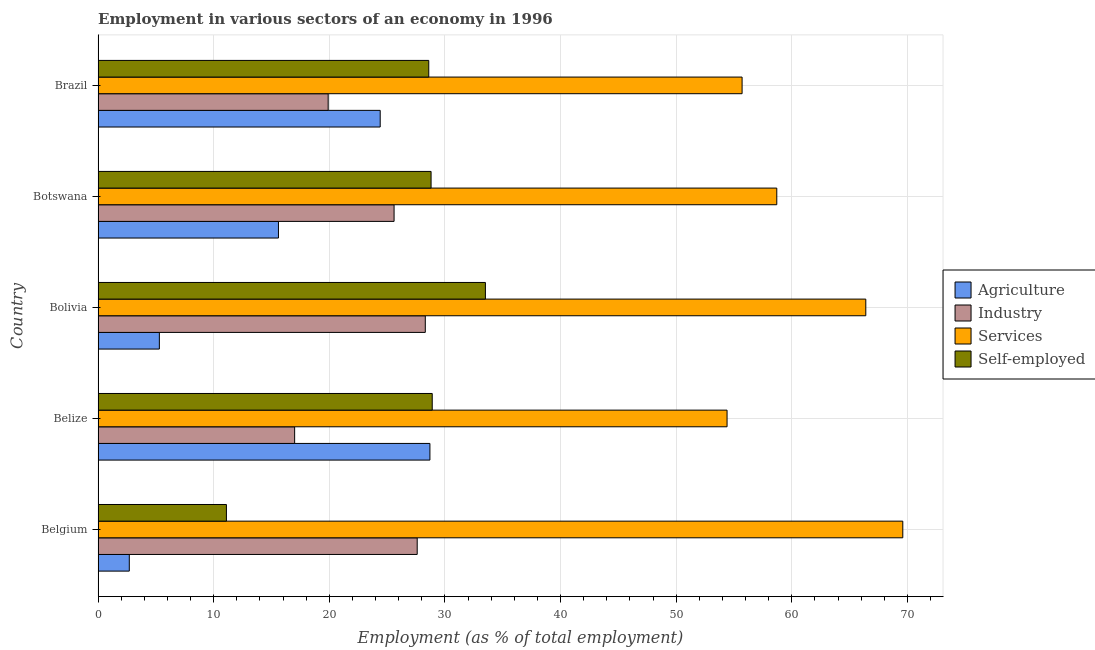Are the number of bars on each tick of the Y-axis equal?
Give a very brief answer. Yes. What is the percentage of workers in services in Belgium?
Your answer should be very brief. 69.6. Across all countries, what is the maximum percentage of workers in agriculture?
Provide a short and direct response. 28.7. Across all countries, what is the minimum percentage of workers in agriculture?
Provide a short and direct response. 2.7. In which country was the percentage of self employed workers maximum?
Make the answer very short. Bolivia. In which country was the percentage of workers in industry minimum?
Ensure brevity in your answer.  Belize. What is the total percentage of workers in industry in the graph?
Keep it short and to the point. 118.4. What is the difference between the percentage of workers in industry in Belgium and that in Brazil?
Give a very brief answer. 7.7. What is the difference between the percentage of workers in industry in Brazil and the percentage of workers in agriculture in Bolivia?
Provide a short and direct response. 14.6. What is the average percentage of workers in industry per country?
Make the answer very short. 23.68. In how many countries, is the percentage of workers in services greater than 10 %?
Give a very brief answer. 5. What is the ratio of the percentage of workers in services in Belize to that in Botswana?
Ensure brevity in your answer.  0.93. Is the percentage of workers in agriculture in Botswana less than that in Brazil?
Offer a terse response. Yes. Is the difference between the percentage of self employed workers in Belgium and Belize greater than the difference between the percentage of workers in services in Belgium and Belize?
Make the answer very short. No. What is the difference between the highest and the second highest percentage of workers in agriculture?
Your answer should be compact. 4.3. In how many countries, is the percentage of self employed workers greater than the average percentage of self employed workers taken over all countries?
Your response must be concise. 4. Is the sum of the percentage of workers in industry in Botswana and Brazil greater than the maximum percentage of workers in agriculture across all countries?
Your answer should be compact. Yes. What does the 1st bar from the top in Brazil represents?
Your answer should be very brief. Self-employed. What does the 4th bar from the bottom in Brazil represents?
Ensure brevity in your answer.  Self-employed. How many countries are there in the graph?
Offer a very short reply. 5. Does the graph contain any zero values?
Keep it short and to the point. No. How many legend labels are there?
Give a very brief answer. 4. What is the title of the graph?
Make the answer very short. Employment in various sectors of an economy in 1996. Does "Portugal" appear as one of the legend labels in the graph?
Give a very brief answer. No. What is the label or title of the X-axis?
Your answer should be compact. Employment (as % of total employment). What is the Employment (as % of total employment) in Agriculture in Belgium?
Ensure brevity in your answer.  2.7. What is the Employment (as % of total employment) of Industry in Belgium?
Ensure brevity in your answer.  27.6. What is the Employment (as % of total employment) of Services in Belgium?
Your response must be concise. 69.6. What is the Employment (as % of total employment) of Self-employed in Belgium?
Your answer should be very brief. 11.1. What is the Employment (as % of total employment) of Agriculture in Belize?
Your response must be concise. 28.7. What is the Employment (as % of total employment) of Industry in Belize?
Provide a short and direct response. 17. What is the Employment (as % of total employment) in Services in Belize?
Offer a terse response. 54.4. What is the Employment (as % of total employment) in Self-employed in Belize?
Provide a short and direct response. 28.9. What is the Employment (as % of total employment) of Agriculture in Bolivia?
Your answer should be compact. 5.3. What is the Employment (as % of total employment) in Industry in Bolivia?
Your response must be concise. 28.3. What is the Employment (as % of total employment) of Services in Bolivia?
Offer a very short reply. 66.4. What is the Employment (as % of total employment) of Self-employed in Bolivia?
Your answer should be very brief. 33.5. What is the Employment (as % of total employment) in Agriculture in Botswana?
Keep it short and to the point. 15.6. What is the Employment (as % of total employment) of Industry in Botswana?
Keep it short and to the point. 25.6. What is the Employment (as % of total employment) of Services in Botswana?
Offer a very short reply. 58.7. What is the Employment (as % of total employment) in Self-employed in Botswana?
Provide a succinct answer. 28.8. What is the Employment (as % of total employment) of Agriculture in Brazil?
Your answer should be compact. 24.4. What is the Employment (as % of total employment) of Industry in Brazil?
Keep it short and to the point. 19.9. What is the Employment (as % of total employment) of Services in Brazil?
Give a very brief answer. 55.7. What is the Employment (as % of total employment) of Self-employed in Brazil?
Ensure brevity in your answer.  28.6. Across all countries, what is the maximum Employment (as % of total employment) of Agriculture?
Ensure brevity in your answer.  28.7. Across all countries, what is the maximum Employment (as % of total employment) of Industry?
Provide a short and direct response. 28.3. Across all countries, what is the maximum Employment (as % of total employment) of Services?
Your answer should be very brief. 69.6. Across all countries, what is the maximum Employment (as % of total employment) of Self-employed?
Keep it short and to the point. 33.5. Across all countries, what is the minimum Employment (as % of total employment) in Agriculture?
Offer a terse response. 2.7. Across all countries, what is the minimum Employment (as % of total employment) of Services?
Ensure brevity in your answer.  54.4. Across all countries, what is the minimum Employment (as % of total employment) in Self-employed?
Make the answer very short. 11.1. What is the total Employment (as % of total employment) in Agriculture in the graph?
Your answer should be compact. 76.7. What is the total Employment (as % of total employment) of Industry in the graph?
Your answer should be compact. 118.4. What is the total Employment (as % of total employment) in Services in the graph?
Make the answer very short. 304.8. What is the total Employment (as % of total employment) of Self-employed in the graph?
Ensure brevity in your answer.  130.9. What is the difference between the Employment (as % of total employment) of Agriculture in Belgium and that in Belize?
Offer a very short reply. -26. What is the difference between the Employment (as % of total employment) of Industry in Belgium and that in Belize?
Provide a succinct answer. 10.6. What is the difference between the Employment (as % of total employment) in Self-employed in Belgium and that in Belize?
Keep it short and to the point. -17.8. What is the difference between the Employment (as % of total employment) in Agriculture in Belgium and that in Bolivia?
Give a very brief answer. -2.6. What is the difference between the Employment (as % of total employment) of Services in Belgium and that in Bolivia?
Your answer should be compact. 3.2. What is the difference between the Employment (as % of total employment) in Self-employed in Belgium and that in Bolivia?
Give a very brief answer. -22.4. What is the difference between the Employment (as % of total employment) in Self-employed in Belgium and that in Botswana?
Provide a succinct answer. -17.7. What is the difference between the Employment (as % of total employment) in Agriculture in Belgium and that in Brazil?
Keep it short and to the point. -21.7. What is the difference between the Employment (as % of total employment) in Industry in Belgium and that in Brazil?
Offer a terse response. 7.7. What is the difference between the Employment (as % of total employment) in Services in Belgium and that in Brazil?
Your answer should be compact. 13.9. What is the difference between the Employment (as % of total employment) of Self-employed in Belgium and that in Brazil?
Ensure brevity in your answer.  -17.5. What is the difference between the Employment (as % of total employment) of Agriculture in Belize and that in Bolivia?
Keep it short and to the point. 23.4. What is the difference between the Employment (as % of total employment) in Services in Belize and that in Bolivia?
Keep it short and to the point. -12. What is the difference between the Employment (as % of total employment) of Agriculture in Belize and that in Botswana?
Give a very brief answer. 13.1. What is the difference between the Employment (as % of total employment) in Industry in Belize and that in Botswana?
Your answer should be very brief. -8.6. What is the difference between the Employment (as % of total employment) in Services in Belize and that in Botswana?
Make the answer very short. -4.3. What is the difference between the Employment (as % of total employment) of Self-employed in Belize and that in Botswana?
Offer a terse response. 0.1. What is the difference between the Employment (as % of total employment) of Agriculture in Belize and that in Brazil?
Make the answer very short. 4.3. What is the difference between the Employment (as % of total employment) of Services in Belize and that in Brazil?
Provide a succinct answer. -1.3. What is the difference between the Employment (as % of total employment) in Self-employed in Belize and that in Brazil?
Your response must be concise. 0.3. What is the difference between the Employment (as % of total employment) in Agriculture in Bolivia and that in Botswana?
Make the answer very short. -10.3. What is the difference between the Employment (as % of total employment) in Self-employed in Bolivia and that in Botswana?
Make the answer very short. 4.7. What is the difference between the Employment (as % of total employment) of Agriculture in Bolivia and that in Brazil?
Offer a terse response. -19.1. What is the difference between the Employment (as % of total employment) in Self-employed in Bolivia and that in Brazil?
Offer a very short reply. 4.9. What is the difference between the Employment (as % of total employment) in Agriculture in Botswana and that in Brazil?
Your response must be concise. -8.8. What is the difference between the Employment (as % of total employment) in Agriculture in Belgium and the Employment (as % of total employment) in Industry in Belize?
Keep it short and to the point. -14.3. What is the difference between the Employment (as % of total employment) of Agriculture in Belgium and the Employment (as % of total employment) of Services in Belize?
Your answer should be very brief. -51.7. What is the difference between the Employment (as % of total employment) in Agriculture in Belgium and the Employment (as % of total employment) in Self-employed in Belize?
Keep it short and to the point. -26.2. What is the difference between the Employment (as % of total employment) of Industry in Belgium and the Employment (as % of total employment) of Services in Belize?
Ensure brevity in your answer.  -26.8. What is the difference between the Employment (as % of total employment) in Services in Belgium and the Employment (as % of total employment) in Self-employed in Belize?
Give a very brief answer. 40.7. What is the difference between the Employment (as % of total employment) of Agriculture in Belgium and the Employment (as % of total employment) of Industry in Bolivia?
Make the answer very short. -25.6. What is the difference between the Employment (as % of total employment) in Agriculture in Belgium and the Employment (as % of total employment) in Services in Bolivia?
Your answer should be very brief. -63.7. What is the difference between the Employment (as % of total employment) in Agriculture in Belgium and the Employment (as % of total employment) in Self-employed in Bolivia?
Keep it short and to the point. -30.8. What is the difference between the Employment (as % of total employment) of Industry in Belgium and the Employment (as % of total employment) of Services in Bolivia?
Give a very brief answer. -38.8. What is the difference between the Employment (as % of total employment) of Services in Belgium and the Employment (as % of total employment) of Self-employed in Bolivia?
Your answer should be compact. 36.1. What is the difference between the Employment (as % of total employment) of Agriculture in Belgium and the Employment (as % of total employment) of Industry in Botswana?
Provide a short and direct response. -22.9. What is the difference between the Employment (as % of total employment) in Agriculture in Belgium and the Employment (as % of total employment) in Services in Botswana?
Give a very brief answer. -56. What is the difference between the Employment (as % of total employment) in Agriculture in Belgium and the Employment (as % of total employment) in Self-employed in Botswana?
Offer a very short reply. -26.1. What is the difference between the Employment (as % of total employment) in Industry in Belgium and the Employment (as % of total employment) in Services in Botswana?
Provide a succinct answer. -31.1. What is the difference between the Employment (as % of total employment) in Services in Belgium and the Employment (as % of total employment) in Self-employed in Botswana?
Keep it short and to the point. 40.8. What is the difference between the Employment (as % of total employment) in Agriculture in Belgium and the Employment (as % of total employment) in Industry in Brazil?
Your response must be concise. -17.2. What is the difference between the Employment (as % of total employment) of Agriculture in Belgium and the Employment (as % of total employment) of Services in Brazil?
Ensure brevity in your answer.  -53. What is the difference between the Employment (as % of total employment) of Agriculture in Belgium and the Employment (as % of total employment) of Self-employed in Brazil?
Offer a very short reply. -25.9. What is the difference between the Employment (as % of total employment) in Industry in Belgium and the Employment (as % of total employment) in Services in Brazil?
Your answer should be very brief. -28.1. What is the difference between the Employment (as % of total employment) in Services in Belgium and the Employment (as % of total employment) in Self-employed in Brazil?
Your answer should be compact. 41. What is the difference between the Employment (as % of total employment) in Agriculture in Belize and the Employment (as % of total employment) in Services in Bolivia?
Ensure brevity in your answer.  -37.7. What is the difference between the Employment (as % of total employment) in Agriculture in Belize and the Employment (as % of total employment) in Self-employed in Bolivia?
Your answer should be very brief. -4.8. What is the difference between the Employment (as % of total employment) in Industry in Belize and the Employment (as % of total employment) in Services in Bolivia?
Offer a very short reply. -49.4. What is the difference between the Employment (as % of total employment) of Industry in Belize and the Employment (as % of total employment) of Self-employed in Bolivia?
Provide a short and direct response. -16.5. What is the difference between the Employment (as % of total employment) of Services in Belize and the Employment (as % of total employment) of Self-employed in Bolivia?
Your answer should be very brief. 20.9. What is the difference between the Employment (as % of total employment) in Industry in Belize and the Employment (as % of total employment) in Services in Botswana?
Offer a very short reply. -41.7. What is the difference between the Employment (as % of total employment) in Industry in Belize and the Employment (as % of total employment) in Self-employed in Botswana?
Make the answer very short. -11.8. What is the difference between the Employment (as % of total employment) in Services in Belize and the Employment (as % of total employment) in Self-employed in Botswana?
Ensure brevity in your answer.  25.6. What is the difference between the Employment (as % of total employment) of Agriculture in Belize and the Employment (as % of total employment) of Services in Brazil?
Make the answer very short. -27. What is the difference between the Employment (as % of total employment) of Industry in Belize and the Employment (as % of total employment) of Services in Brazil?
Offer a terse response. -38.7. What is the difference between the Employment (as % of total employment) of Services in Belize and the Employment (as % of total employment) of Self-employed in Brazil?
Your response must be concise. 25.8. What is the difference between the Employment (as % of total employment) in Agriculture in Bolivia and the Employment (as % of total employment) in Industry in Botswana?
Offer a terse response. -20.3. What is the difference between the Employment (as % of total employment) in Agriculture in Bolivia and the Employment (as % of total employment) in Services in Botswana?
Offer a terse response. -53.4. What is the difference between the Employment (as % of total employment) in Agriculture in Bolivia and the Employment (as % of total employment) in Self-employed in Botswana?
Give a very brief answer. -23.5. What is the difference between the Employment (as % of total employment) of Industry in Bolivia and the Employment (as % of total employment) of Services in Botswana?
Provide a short and direct response. -30.4. What is the difference between the Employment (as % of total employment) of Industry in Bolivia and the Employment (as % of total employment) of Self-employed in Botswana?
Provide a succinct answer. -0.5. What is the difference between the Employment (as % of total employment) of Services in Bolivia and the Employment (as % of total employment) of Self-employed in Botswana?
Provide a succinct answer. 37.6. What is the difference between the Employment (as % of total employment) in Agriculture in Bolivia and the Employment (as % of total employment) in Industry in Brazil?
Your response must be concise. -14.6. What is the difference between the Employment (as % of total employment) of Agriculture in Bolivia and the Employment (as % of total employment) of Services in Brazil?
Your response must be concise. -50.4. What is the difference between the Employment (as % of total employment) of Agriculture in Bolivia and the Employment (as % of total employment) of Self-employed in Brazil?
Keep it short and to the point. -23.3. What is the difference between the Employment (as % of total employment) in Industry in Bolivia and the Employment (as % of total employment) in Services in Brazil?
Make the answer very short. -27.4. What is the difference between the Employment (as % of total employment) of Industry in Bolivia and the Employment (as % of total employment) of Self-employed in Brazil?
Provide a short and direct response. -0.3. What is the difference between the Employment (as % of total employment) in Services in Bolivia and the Employment (as % of total employment) in Self-employed in Brazil?
Keep it short and to the point. 37.8. What is the difference between the Employment (as % of total employment) in Agriculture in Botswana and the Employment (as % of total employment) in Services in Brazil?
Offer a very short reply. -40.1. What is the difference between the Employment (as % of total employment) of Industry in Botswana and the Employment (as % of total employment) of Services in Brazil?
Offer a very short reply. -30.1. What is the difference between the Employment (as % of total employment) in Industry in Botswana and the Employment (as % of total employment) in Self-employed in Brazil?
Your response must be concise. -3. What is the difference between the Employment (as % of total employment) of Services in Botswana and the Employment (as % of total employment) of Self-employed in Brazil?
Provide a succinct answer. 30.1. What is the average Employment (as % of total employment) of Agriculture per country?
Give a very brief answer. 15.34. What is the average Employment (as % of total employment) in Industry per country?
Provide a succinct answer. 23.68. What is the average Employment (as % of total employment) in Services per country?
Give a very brief answer. 60.96. What is the average Employment (as % of total employment) in Self-employed per country?
Offer a terse response. 26.18. What is the difference between the Employment (as % of total employment) of Agriculture and Employment (as % of total employment) of Industry in Belgium?
Provide a short and direct response. -24.9. What is the difference between the Employment (as % of total employment) of Agriculture and Employment (as % of total employment) of Services in Belgium?
Keep it short and to the point. -66.9. What is the difference between the Employment (as % of total employment) in Agriculture and Employment (as % of total employment) in Self-employed in Belgium?
Provide a short and direct response. -8.4. What is the difference between the Employment (as % of total employment) of Industry and Employment (as % of total employment) of Services in Belgium?
Make the answer very short. -42. What is the difference between the Employment (as % of total employment) of Industry and Employment (as % of total employment) of Self-employed in Belgium?
Offer a terse response. 16.5. What is the difference between the Employment (as % of total employment) in Services and Employment (as % of total employment) in Self-employed in Belgium?
Give a very brief answer. 58.5. What is the difference between the Employment (as % of total employment) in Agriculture and Employment (as % of total employment) in Services in Belize?
Provide a short and direct response. -25.7. What is the difference between the Employment (as % of total employment) in Industry and Employment (as % of total employment) in Services in Belize?
Your answer should be very brief. -37.4. What is the difference between the Employment (as % of total employment) of Agriculture and Employment (as % of total employment) of Services in Bolivia?
Your response must be concise. -61.1. What is the difference between the Employment (as % of total employment) in Agriculture and Employment (as % of total employment) in Self-employed in Bolivia?
Offer a very short reply. -28.2. What is the difference between the Employment (as % of total employment) of Industry and Employment (as % of total employment) of Services in Bolivia?
Give a very brief answer. -38.1. What is the difference between the Employment (as % of total employment) of Services and Employment (as % of total employment) of Self-employed in Bolivia?
Keep it short and to the point. 32.9. What is the difference between the Employment (as % of total employment) in Agriculture and Employment (as % of total employment) in Industry in Botswana?
Offer a terse response. -10. What is the difference between the Employment (as % of total employment) in Agriculture and Employment (as % of total employment) in Services in Botswana?
Your response must be concise. -43.1. What is the difference between the Employment (as % of total employment) of Agriculture and Employment (as % of total employment) of Self-employed in Botswana?
Your answer should be compact. -13.2. What is the difference between the Employment (as % of total employment) in Industry and Employment (as % of total employment) in Services in Botswana?
Your response must be concise. -33.1. What is the difference between the Employment (as % of total employment) of Services and Employment (as % of total employment) of Self-employed in Botswana?
Offer a very short reply. 29.9. What is the difference between the Employment (as % of total employment) of Agriculture and Employment (as % of total employment) of Industry in Brazil?
Ensure brevity in your answer.  4.5. What is the difference between the Employment (as % of total employment) in Agriculture and Employment (as % of total employment) in Services in Brazil?
Keep it short and to the point. -31.3. What is the difference between the Employment (as % of total employment) of Industry and Employment (as % of total employment) of Services in Brazil?
Ensure brevity in your answer.  -35.8. What is the difference between the Employment (as % of total employment) of Industry and Employment (as % of total employment) of Self-employed in Brazil?
Give a very brief answer. -8.7. What is the difference between the Employment (as % of total employment) in Services and Employment (as % of total employment) in Self-employed in Brazil?
Give a very brief answer. 27.1. What is the ratio of the Employment (as % of total employment) of Agriculture in Belgium to that in Belize?
Make the answer very short. 0.09. What is the ratio of the Employment (as % of total employment) of Industry in Belgium to that in Belize?
Give a very brief answer. 1.62. What is the ratio of the Employment (as % of total employment) in Services in Belgium to that in Belize?
Keep it short and to the point. 1.28. What is the ratio of the Employment (as % of total employment) in Self-employed in Belgium to that in Belize?
Your response must be concise. 0.38. What is the ratio of the Employment (as % of total employment) of Agriculture in Belgium to that in Bolivia?
Ensure brevity in your answer.  0.51. What is the ratio of the Employment (as % of total employment) in Industry in Belgium to that in Bolivia?
Keep it short and to the point. 0.98. What is the ratio of the Employment (as % of total employment) in Services in Belgium to that in Bolivia?
Give a very brief answer. 1.05. What is the ratio of the Employment (as % of total employment) in Self-employed in Belgium to that in Bolivia?
Ensure brevity in your answer.  0.33. What is the ratio of the Employment (as % of total employment) of Agriculture in Belgium to that in Botswana?
Provide a succinct answer. 0.17. What is the ratio of the Employment (as % of total employment) of Industry in Belgium to that in Botswana?
Ensure brevity in your answer.  1.08. What is the ratio of the Employment (as % of total employment) of Services in Belgium to that in Botswana?
Provide a succinct answer. 1.19. What is the ratio of the Employment (as % of total employment) of Self-employed in Belgium to that in Botswana?
Make the answer very short. 0.39. What is the ratio of the Employment (as % of total employment) of Agriculture in Belgium to that in Brazil?
Offer a terse response. 0.11. What is the ratio of the Employment (as % of total employment) in Industry in Belgium to that in Brazil?
Your response must be concise. 1.39. What is the ratio of the Employment (as % of total employment) in Services in Belgium to that in Brazil?
Give a very brief answer. 1.25. What is the ratio of the Employment (as % of total employment) of Self-employed in Belgium to that in Brazil?
Provide a succinct answer. 0.39. What is the ratio of the Employment (as % of total employment) of Agriculture in Belize to that in Bolivia?
Make the answer very short. 5.42. What is the ratio of the Employment (as % of total employment) of Industry in Belize to that in Bolivia?
Keep it short and to the point. 0.6. What is the ratio of the Employment (as % of total employment) of Services in Belize to that in Bolivia?
Provide a short and direct response. 0.82. What is the ratio of the Employment (as % of total employment) in Self-employed in Belize to that in Bolivia?
Ensure brevity in your answer.  0.86. What is the ratio of the Employment (as % of total employment) in Agriculture in Belize to that in Botswana?
Make the answer very short. 1.84. What is the ratio of the Employment (as % of total employment) in Industry in Belize to that in Botswana?
Your answer should be compact. 0.66. What is the ratio of the Employment (as % of total employment) of Services in Belize to that in Botswana?
Keep it short and to the point. 0.93. What is the ratio of the Employment (as % of total employment) in Agriculture in Belize to that in Brazil?
Offer a very short reply. 1.18. What is the ratio of the Employment (as % of total employment) of Industry in Belize to that in Brazil?
Your answer should be very brief. 0.85. What is the ratio of the Employment (as % of total employment) in Services in Belize to that in Brazil?
Keep it short and to the point. 0.98. What is the ratio of the Employment (as % of total employment) in Self-employed in Belize to that in Brazil?
Provide a succinct answer. 1.01. What is the ratio of the Employment (as % of total employment) in Agriculture in Bolivia to that in Botswana?
Offer a terse response. 0.34. What is the ratio of the Employment (as % of total employment) in Industry in Bolivia to that in Botswana?
Make the answer very short. 1.11. What is the ratio of the Employment (as % of total employment) of Services in Bolivia to that in Botswana?
Provide a short and direct response. 1.13. What is the ratio of the Employment (as % of total employment) in Self-employed in Bolivia to that in Botswana?
Provide a succinct answer. 1.16. What is the ratio of the Employment (as % of total employment) in Agriculture in Bolivia to that in Brazil?
Ensure brevity in your answer.  0.22. What is the ratio of the Employment (as % of total employment) of Industry in Bolivia to that in Brazil?
Ensure brevity in your answer.  1.42. What is the ratio of the Employment (as % of total employment) in Services in Bolivia to that in Brazil?
Your answer should be compact. 1.19. What is the ratio of the Employment (as % of total employment) of Self-employed in Bolivia to that in Brazil?
Provide a short and direct response. 1.17. What is the ratio of the Employment (as % of total employment) in Agriculture in Botswana to that in Brazil?
Provide a succinct answer. 0.64. What is the ratio of the Employment (as % of total employment) in Industry in Botswana to that in Brazil?
Make the answer very short. 1.29. What is the ratio of the Employment (as % of total employment) of Services in Botswana to that in Brazil?
Ensure brevity in your answer.  1.05. What is the ratio of the Employment (as % of total employment) in Self-employed in Botswana to that in Brazil?
Offer a terse response. 1.01. What is the difference between the highest and the second highest Employment (as % of total employment) of Agriculture?
Your response must be concise. 4.3. What is the difference between the highest and the second highest Employment (as % of total employment) in Self-employed?
Give a very brief answer. 4.6. What is the difference between the highest and the lowest Employment (as % of total employment) in Agriculture?
Offer a very short reply. 26. What is the difference between the highest and the lowest Employment (as % of total employment) of Industry?
Your answer should be compact. 11.3. What is the difference between the highest and the lowest Employment (as % of total employment) of Self-employed?
Give a very brief answer. 22.4. 